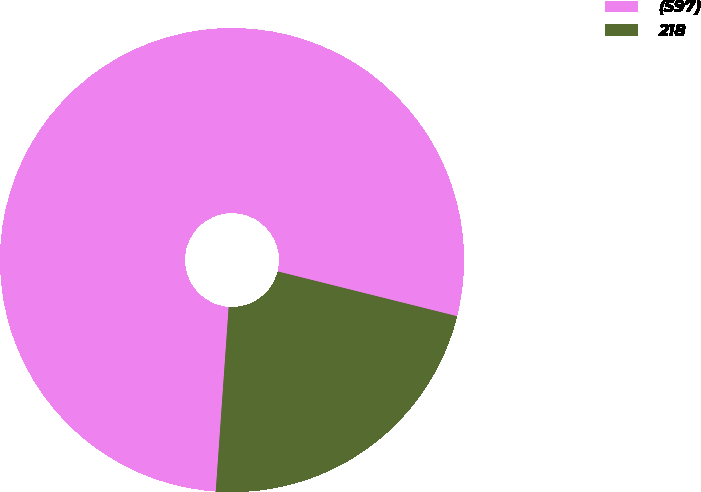<chart> <loc_0><loc_0><loc_500><loc_500><pie_chart><fcel>(597)<fcel>218<nl><fcel>77.78%<fcel>22.22%<nl></chart> 